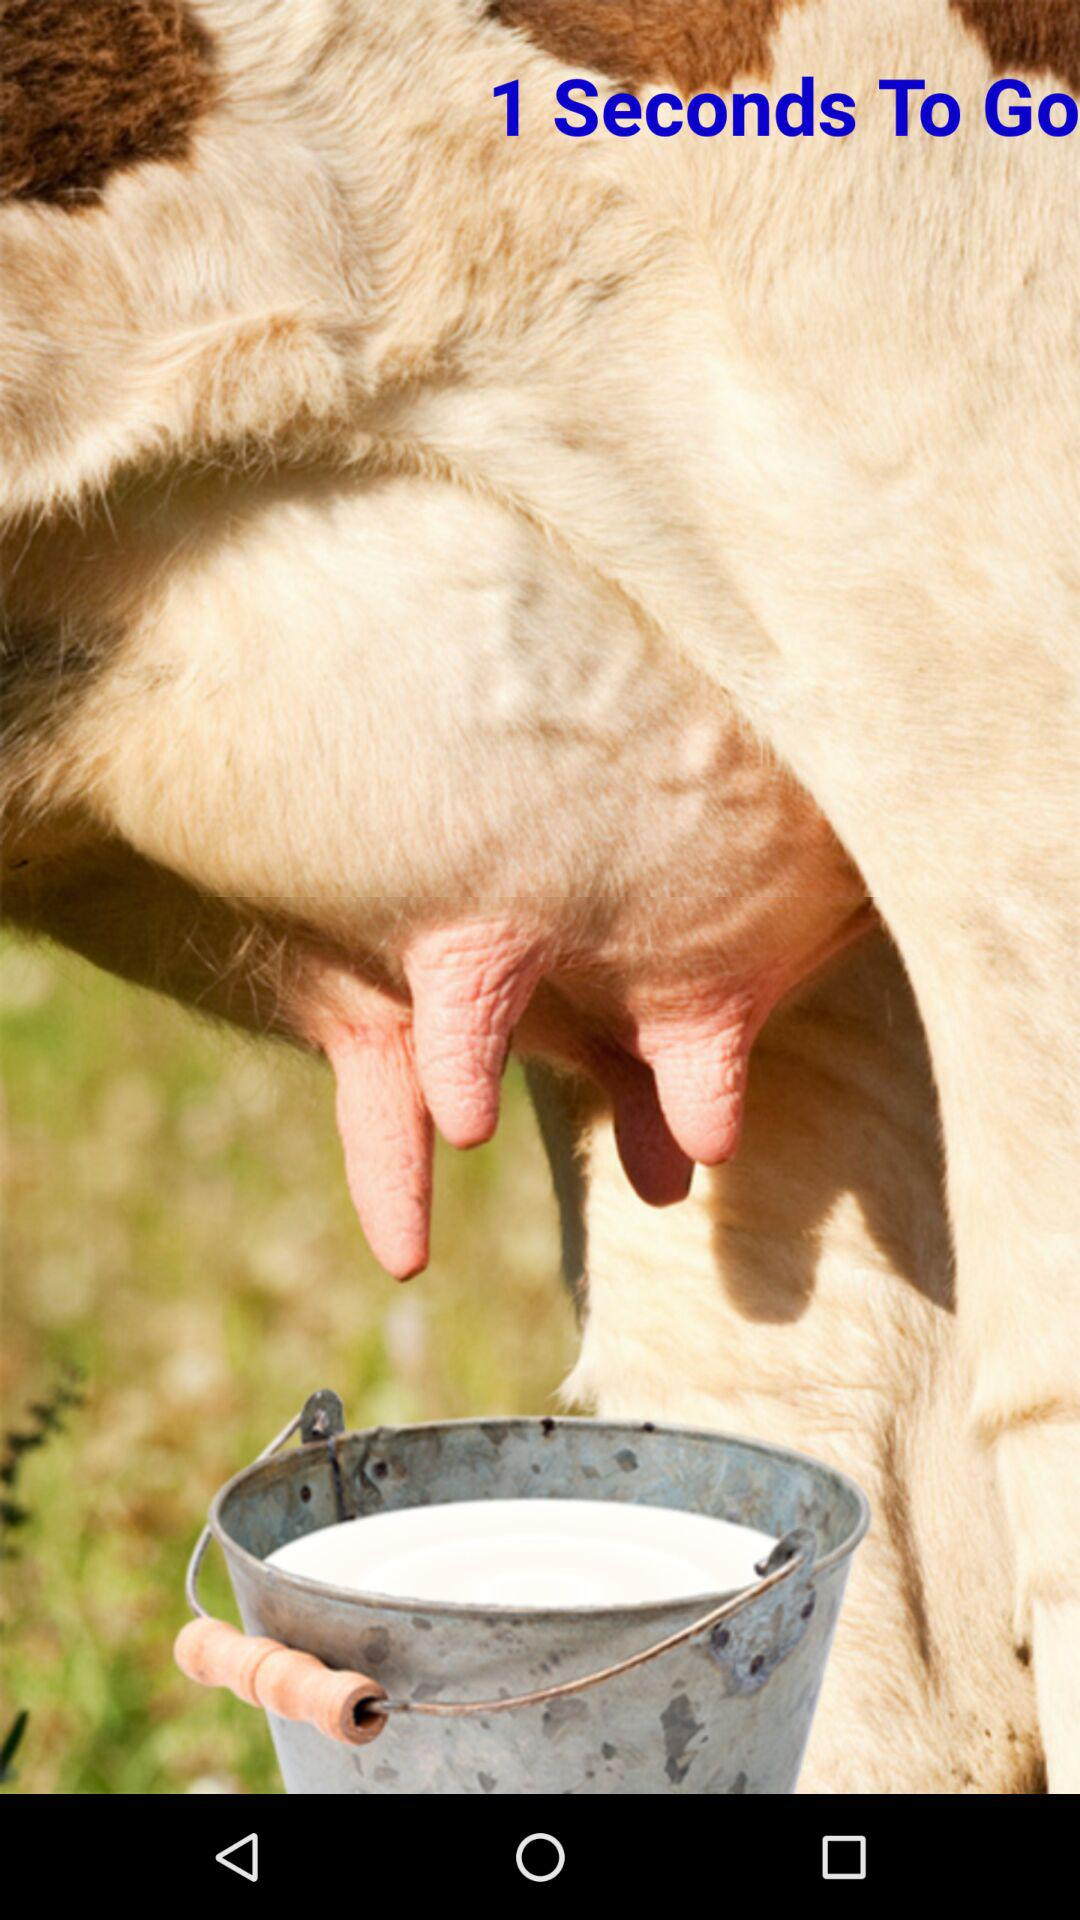How many seconds are there left in the countdown?
Answer the question using a single word or phrase. 1 